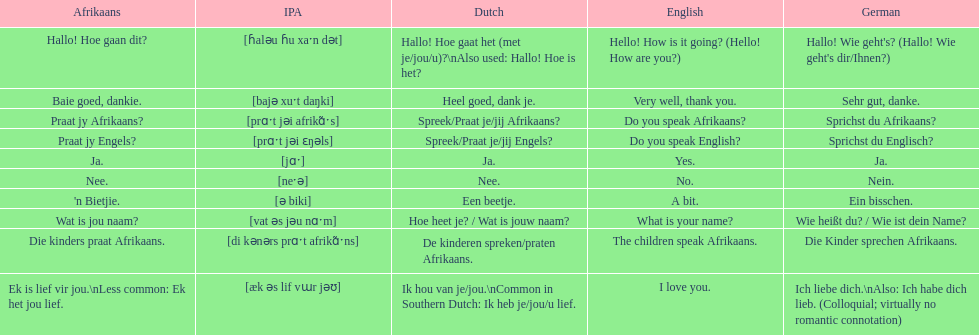How do you utter 'yes' in afrikaans? Ja. 